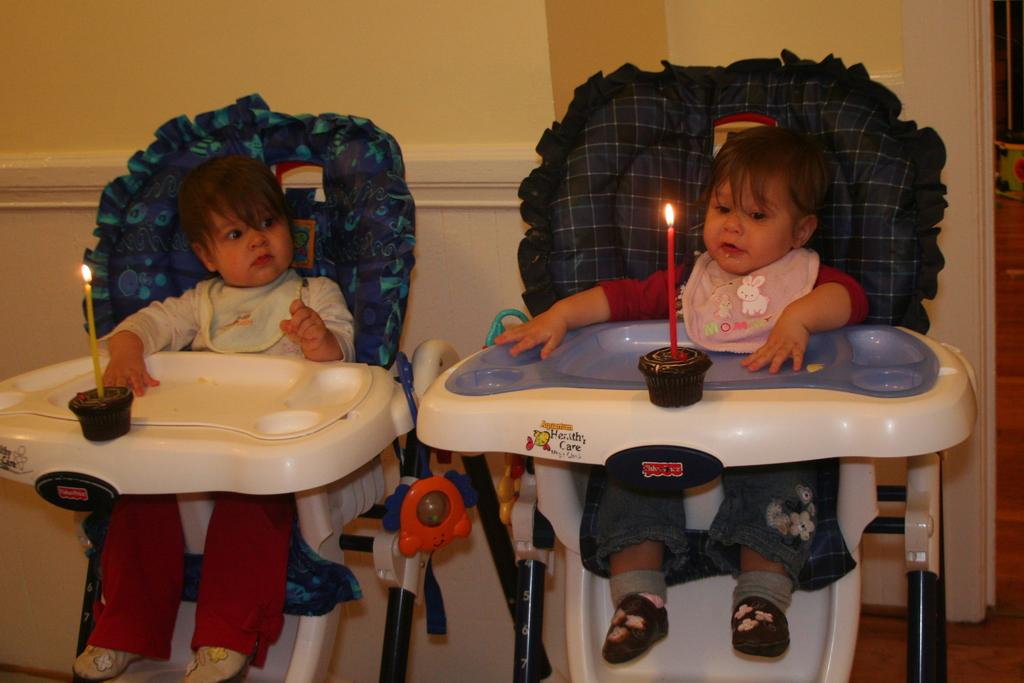How many babies are present in the image? There are two babies in the image. What are the babies sitting on? The babies are sitting on baby chairs. What objects can be seen in front of the babies? There are two candles placed before the babies. What song is the baby on the left singing in the image? There is no indication in the image that the babies are singing, so it cannot be determined which song, if any, the baby on the left might be singing. 